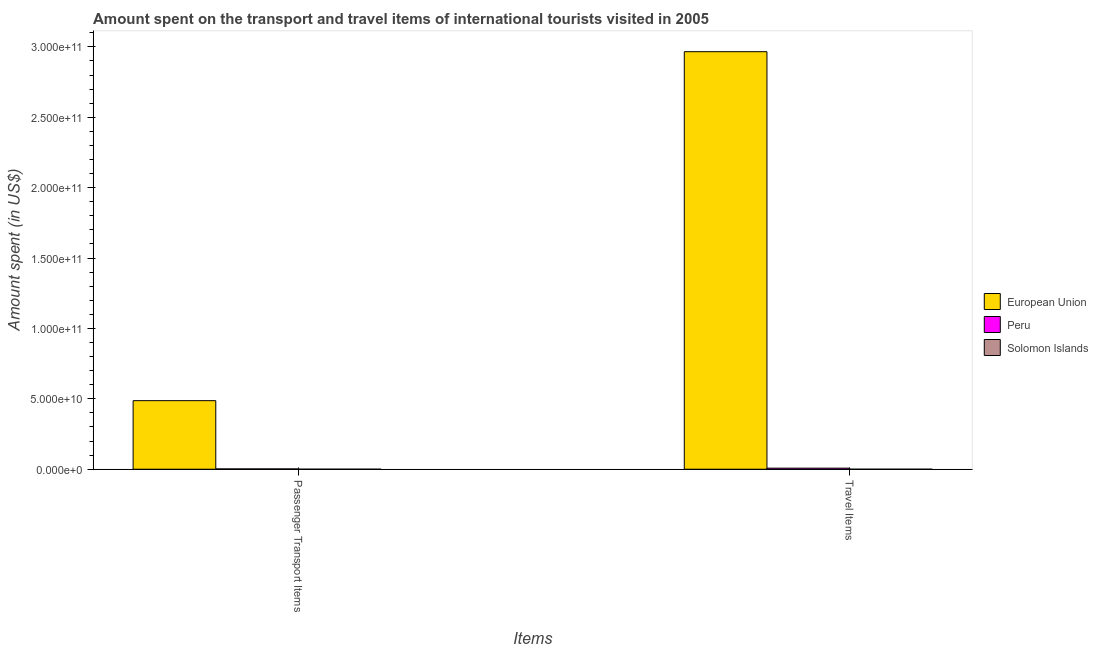How many groups of bars are there?
Offer a very short reply. 2. Are the number of bars on each tick of the X-axis equal?
Your response must be concise. Yes. How many bars are there on the 1st tick from the left?
Make the answer very short. 3. What is the label of the 1st group of bars from the left?
Keep it short and to the point. Passenger Transport Items. What is the amount spent in travel items in European Union?
Your response must be concise. 2.97e+11. Across all countries, what is the maximum amount spent in travel items?
Offer a terse response. 2.97e+11. Across all countries, what is the minimum amount spent on passenger transport items?
Your response must be concise. 6.50e+06. In which country was the amount spent on passenger transport items maximum?
Ensure brevity in your answer.  European Union. In which country was the amount spent on passenger transport items minimum?
Provide a succinct answer. Solomon Islands. What is the total amount spent on passenger transport items in the graph?
Offer a very short reply. 4.89e+1. What is the difference between the amount spent in travel items in Solomon Islands and that in European Union?
Ensure brevity in your answer.  -2.97e+11. What is the difference between the amount spent in travel items in European Union and the amount spent on passenger transport items in Solomon Islands?
Provide a succinct answer. 2.97e+11. What is the average amount spent on passenger transport items per country?
Ensure brevity in your answer.  1.63e+1. What is the difference between the amount spent on passenger transport items and amount spent in travel items in Solomon Islands?
Your answer should be very brief. 1.80e+06. What is the ratio of the amount spent on passenger transport items in Solomon Islands to that in European Union?
Make the answer very short. 0. Is the amount spent in travel items in Solomon Islands less than that in European Union?
Provide a short and direct response. Yes. What does the 3rd bar from the left in Passenger Transport Items represents?
Your response must be concise. Solomon Islands. What does the 1st bar from the right in Passenger Transport Items represents?
Your response must be concise. Solomon Islands. How many bars are there?
Ensure brevity in your answer.  6. Are all the bars in the graph horizontal?
Your answer should be compact. No. How many countries are there in the graph?
Provide a succinct answer. 3. Are the values on the major ticks of Y-axis written in scientific E-notation?
Give a very brief answer. Yes. Does the graph contain any zero values?
Offer a terse response. No. How many legend labels are there?
Give a very brief answer. 3. How are the legend labels stacked?
Make the answer very short. Vertical. What is the title of the graph?
Your answer should be compact. Amount spent on the transport and travel items of international tourists visited in 2005. What is the label or title of the X-axis?
Keep it short and to the point. Items. What is the label or title of the Y-axis?
Keep it short and to the point. Amount spent (in US$). What is the Amount spent (in US$) of European Union in Passenger Transport Items?
Make the answer very short. 4.87e+1. What is the Amount spent (in US$) of Peru in Passenger Transport Items?
Provide a succinct answer. 2.18e+08. What is the Amount spent (in US$) in Solomon Islands in Passenger Transport Items?
Give a very brief answer. 6.50e+06. What is the Amount spent (in US$) of European Union in Travel Items?
Provide a succinct answer. 2.97e+11. What is the Amount spent (in US$) in Peru in Travel Items?
Provide a succinct answer. 7.52e+08. What is the Amount spent (in US$) of Solomon Islands in Travel Items?
Provide a succinct answer. 4.70e+06. Across all Items, what is the maximum Amount spent (in US$) in European Union?
Provide a short and direct response. 2.97e+11. Across all Items, what is the maximum Amount spent (in US$) of Peru?
Provide a succinct answer. 7.52e+08. Across all Items, what is the maximum Amount spent (in US$) of Solomon Islands?
Your answer should be compact. 6.50e+06. Across all Items, what is the minimum Amount spent (in US$) of European Union?
Ensure brevity in your answer.  4.87e+1. Across all Items, what is the minimum Amount spent (in US$) of Peru?
Make the answer very short. 2.18e+08. Across all Items, what is the minimum Amount spent (in US$) of Solomon Islands?
Give a very brief answer. 4.70e+06. What is the total Amount spent (in US$) of European Union in the graph?
Provide a short and direct response. 3.45e+11. What is the total Amount spent (in US$) in Peru in the graph?
Your response must be concise. 9.70e+08. What is the total Amount spent (in US$) in Solomon Islands in the graph?
Your answer should be compact. 1.12e+07. What is the difference between the Amount spent (in US$) in European Union in Passenger Transport Items and that in Travel Items?
Keep it short and to the point. -2.48e+11. What is the difference between the Amount spent (in US$) of Peru in Passenger Transport Items and that in Travel Items?
Keep it short and to the point. -5.34e+08. What is the difference between the Amount spent (in US$) in Solomon Islands in Passenger Transport Items and that in Travel Items?
Provide a succinct answer. 1.80e+06. What is the difference between the Amount spent (in US$) in European Union in Passenger Transport Items and the Amount spent (in US$) in Peru in Travel Items?
Keep it short and to the point. 4.80e+1. What is the difference between the Amount spent (in US$) of European Union in Passenger Transport Items and the Amount spent (in US$) of Solomon Islands in Travel Items?
Ensure brevity in your answer.  4.87e+1. What is the difference between the Amount spent (in US$) in Peru in Passenger Transport Items and the Amount spent (in US$) in Solomon Islands in Travel Items?
Ensure brevity in your answer.  2.13e+08. What is the average Amount spent (in US$) of European Union per Items?
Provide a succinct answer. 1.73e+11. What is the average Amount spent (in US$) in Peru per Items?
Ensure brevity in your answer.  4.85e+08. What is the average Amount spent (in US$) in Solomon Islands per Items?
Give a very brief answer. 5.60e+06. What is the difference between the Amount spent (in US$) of European Union and Amount spent (in US$) of Peru in Passenger Transport Items?
Provide a short and direct response. 4.85e+1. What is the difference between the Amount spent (in US$) of European Union and Amount spent (in US$) of Solomon Islands in Passenger Transport Items?
Provide a succinct answer. 4.87e+1. What is the difference between the Amount spent (in US$) in Peru and Amount spent (in US$) in Solomon Islands in Passenger Transport Items?
Your response must be concise. 2.12e+08. What is the difference between the Amount spent (in US$) in European Union and Amount spent (in US$) in Peru in Travel Items?
Offer a terse response. 2.96e+11. What is the difference between the Amount spent (in US$) of European Union and Amount spent (in US$) of Solomon Islands in Travel Items?
Make the answer very short. 2.97e+11. What is the difference between the Amount spent (in US$) in Peru and Amount spent (in US$) in Solomon Islands in Travel Items?
Your answer should be very brief. 7.47e+08. What is the ratio of the Amount spent (in US$) in European Union in Passenger Transport Items to that in Travel Items?
Make the answer very short. 0.16. What is the ratio of the Amount spent (in US$) of Peru in Passenger Transport Items to that in Travel Items?
Your response must be concise. 0.29. What is the ratio of the Amount spent (in US$) in Solomon Islands in Passenger Transport Items to that in Travel Items?
Provide a short and direct response. 1.38. What is the difference between the highest and the second highest Amount spent (in US$) of European Union?
Offer a very short reply. 2.48e+11. What is the difference between the highest and the second highest Amount spent (in US$) of Peru?
Provide a succinct answer. 5.34e+08. What is the difference between the highest and the second highest Amount spent (in US$) of Solomon Islands?
Ensure brevity in your answer.  1.80e+06. What is the difference between the highest and the lowest Amount spent (in US$) of European Union?
Make the answer very short. 2.48e+11. What is the difference between the highest and the lowest Amount spent (in US$) in Peru?
Offer a very short reply. 5.34e+08. What is the difference between the highest and the lowest Amount spent (in US$) in Solomon Islands?
Provide a succinct answer. 1.80e+06. 